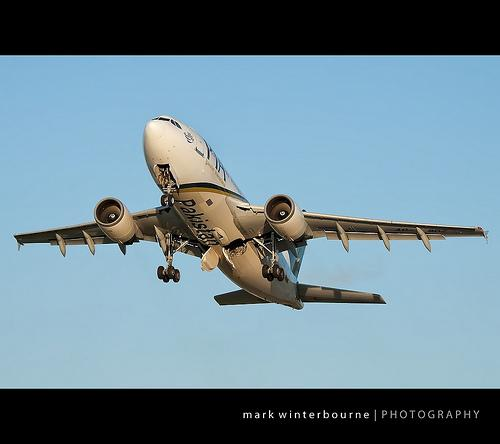Question: what type of motor is on the planes wings?
Choices:
A. Propellers.
B. Wings.
C. Turbines.
D. Jets.
Answer with the letter. Answer: D Question: what color is the strip that isn't blue?
Choices:
A. Gold.
B. Red.
C. Green.
D. Purple.
Answer with the letter. Answer: A Question: what type of vehicle is pictured?
Choices:
A. A scooter.
B. Plane.
C. A bus.
D. A skateboard.
Answer with the letter. Answer: B Question: what is the main color of the plane?
Choices:
A. Green.
B. Blue.
C. White.
D. Red.
Answer with the letter. Answer: C Question: how many clouds are pictured?
Choices:
A. One.
B. None.
C. Two.
D. Three.
Answer with the letter. Answer: B 